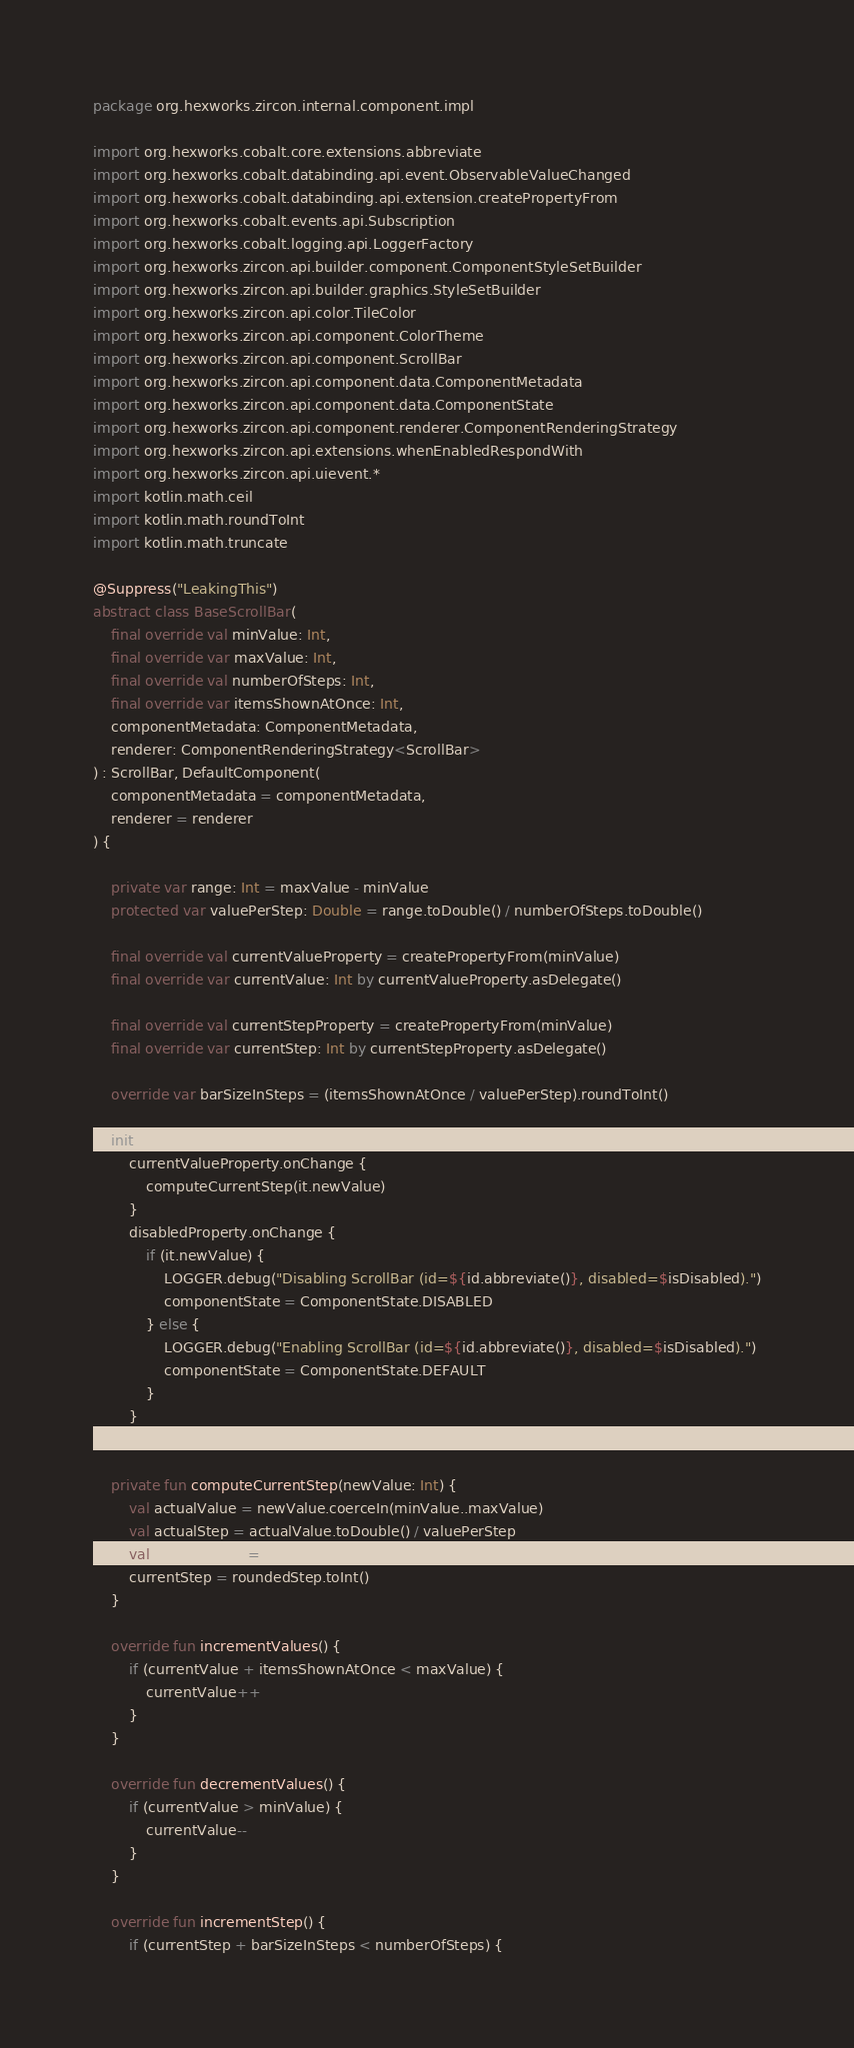Convert code to text. <code><loc_0><loc_0><loc_500><loc_500><_Kotlin_>package org.hexworks.zircon.internal.component.impl

import org.hexworks.cobalt.core.extensions.abbreviate
import org.hexworks.cobalt.databinding.api.event.ObservableValueChanged
import org.hexworks.cobalt.databinding.api.extension.createPropertyFrom
import org.hexworks.cobalt.events.api.Subscription
import org.hexworks.cobalt.logging.api.LoggerFactory
import org.hexworks.zircon.api.builder.component.ComponentStyleSetBuilder
import org.hexworks.zircon.api.builder.graphics.StyleSetBuilder
import org.hexworks.zircon.api.color.TileColor
import org.hexworks.zircon.api.component.ColorTheme
import org.hexworks.zircon.api.component.ScrollBar
import org.hexworks.zircon.api.component.data.ComponentMetadata
import org.hexworks.zircon.api.component.data.ComponentState
import org.hexworks.zircon.api.component.renderer.ComponentRenderingStrategy
import org.hexworks.zircon.api.extensions.whenEnabledRespondWith
import org.hexworks.zircon.api.uievent.*
import kotlin.math.ceil
import kotlin.math.roundToInt
import kotlin.math.truncate

@Suppress("LeakingThis")
abstract class BaseScrollBar(
    final override val minValue: Int,
    final override var maxValue: Int,
    final override val numberOfSteps: Int,
    final override var itemsShownAtOnce: Int,
    componentMetadata: ComponentMetadata,
    renderer: ComponentRenderingStrategy<ScrollBar>
) : ScrollBar, DefaultComponent(
    componentMetadata = componentMetadata,
    renderer = renderer
) {

    private var range: Int = maxValue - minValue
    protected var valuePerStep: Double = range.toDouble() / numberOfSteps.toDouble()

    final override val currentValueProperty = createPropertyFrom(minValue)
    final override var currentValue: Int by currentValueProperty.asDelegate()

    final override val currentStepProperty = createPropertyFrom(minValue)
    final override var currentStep: Int by currentStepProperty.asDelegate()

    override var barSizeInSteps = (itemsShownAtOnce / valuePerStep).roundToInt()

    init {
        currentValueProperty.onChange {
            computeCurrentStep(it.newValue)
        }
        disabledProperty.onChange {
            if (it.newValue) {
                LOGGER.debug("Disabling ScrollBar (id=${id.abbreviate()}, disabled=$isDisabled).")
                componentState = ComponentState.DISABLED
            } else {
                LOGGER.debug("Enabling ScrollBar (id=${id.abbreviate()}, disabled=$isDisabled).")
                componentState = ComponentState.DEFAULT
            }
        }
    }

    private fun computeCurrentStep(newValue: Int) {
        val actualValue = newValue.coerceIn(minValue..maxValue)
        val actualStep = actualValue.toDouble() / valuePerStep
        val roundedStep = truncate(actualStep)
        currentStep = roundedStep.toInt()
    }

    override fun incrementValues() {
        if (currentValue + itemsShownAtOnce < maxValue) {
            currentValue++
        }
    }

    override fun decrementValues() {
        if (currentValue > minValue) {
            currentValue--
        }
    }

    override fun incrementStep() {
        if (currentStep + barSizeInSteps < numberOfSteps) {</code> 